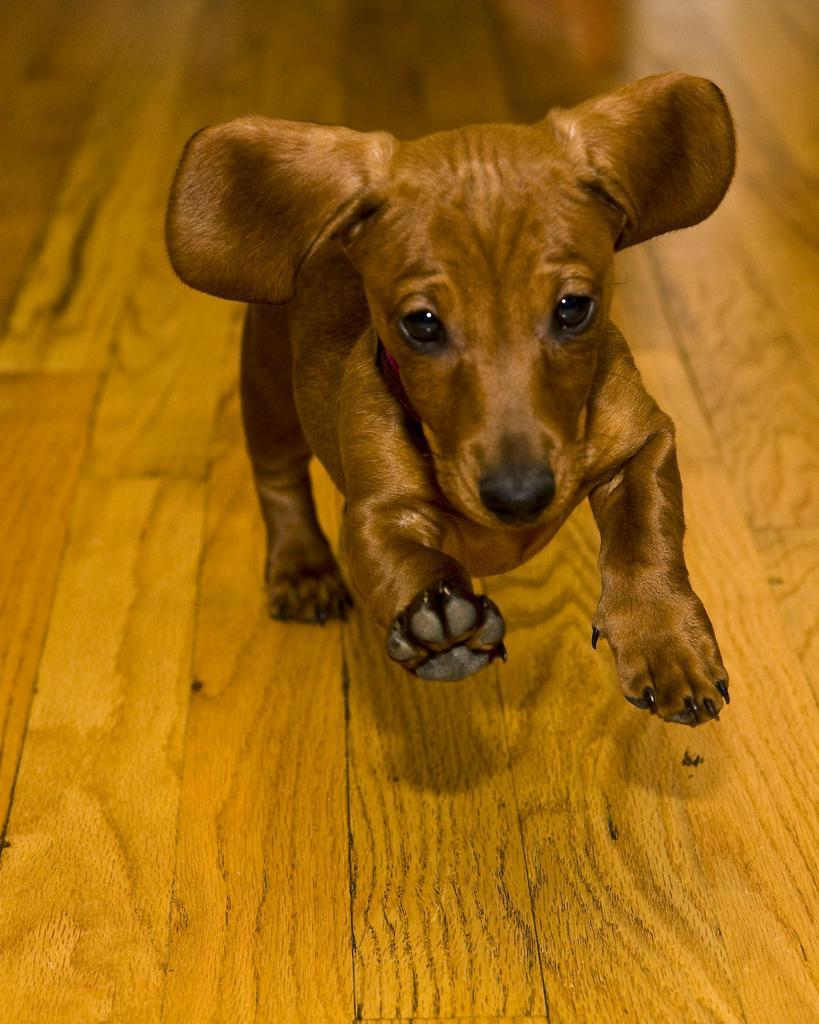What type of animal is in the image? There is a dog in the image. What is the dog standing or sitting on? The dog is on a wooden surface. What type of sock is the dog wearing in the image? There is no sock present in the image; the dog is on a wooden surface. 